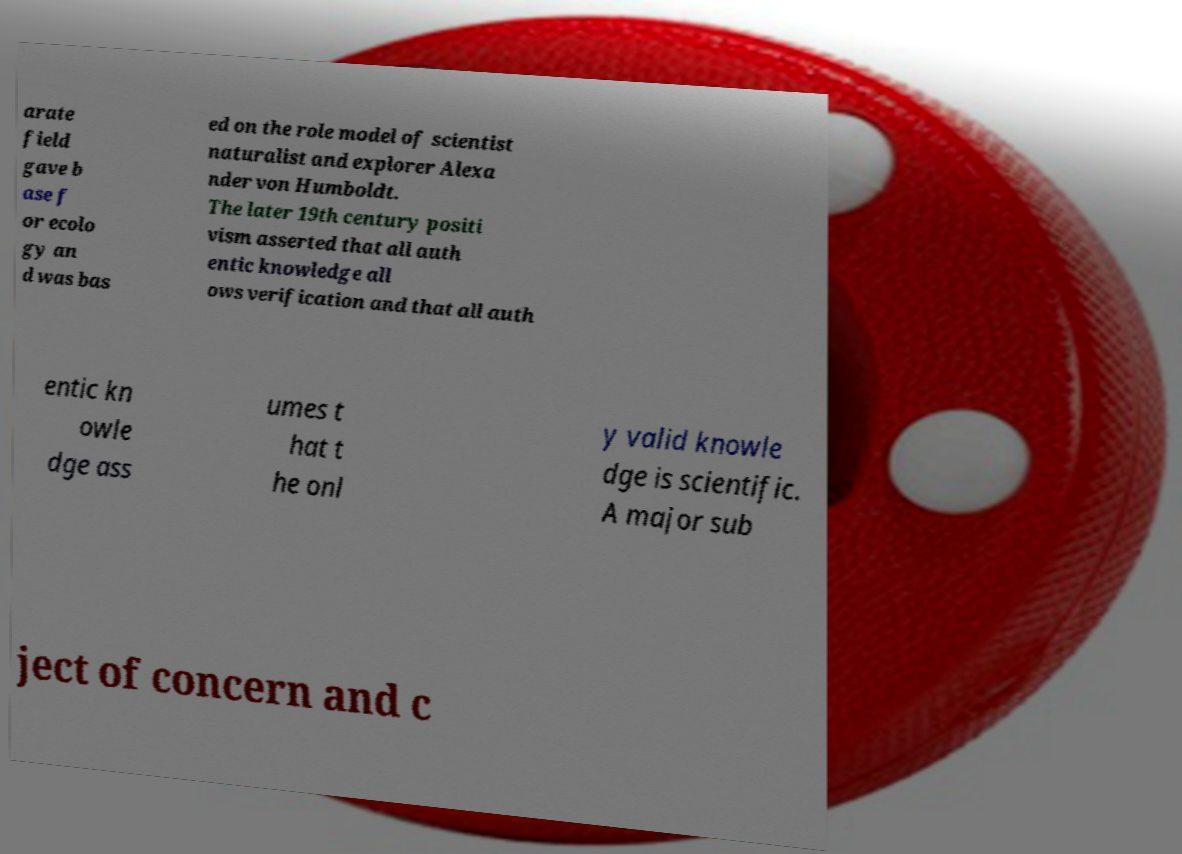There's text embedded in this image that I need extracted. Can you transcribe it verbatim? arate field gave b ase f or ecolo gy an d was bas ed on the role model of scientist naturalist and explorer Alexa nder von Humboldt. The later 19th century positi vism asserted that all auth entic knowledge all ows verification and that all auth entic kn owle dge ass umes t hat t he onl y valid knowle dge is scientific. A major sub ject of concern and c 